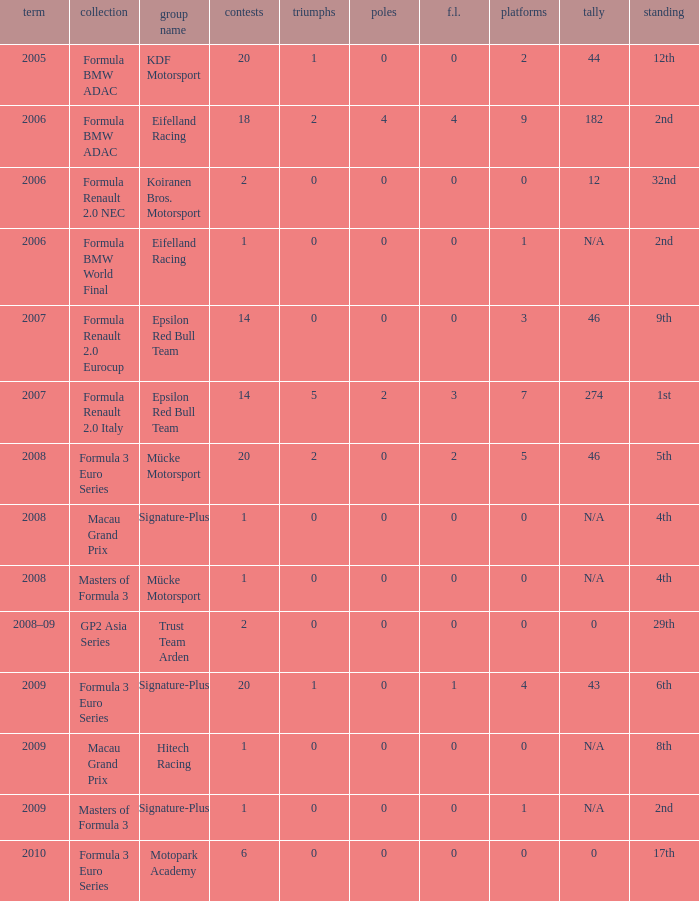What is the average number of podiums in the 32nd position with less than 0 wins? None. 